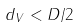<formula> <loc_0><loc_0><loc_500><loc_500>d _ { V } < D / 2</formula> 